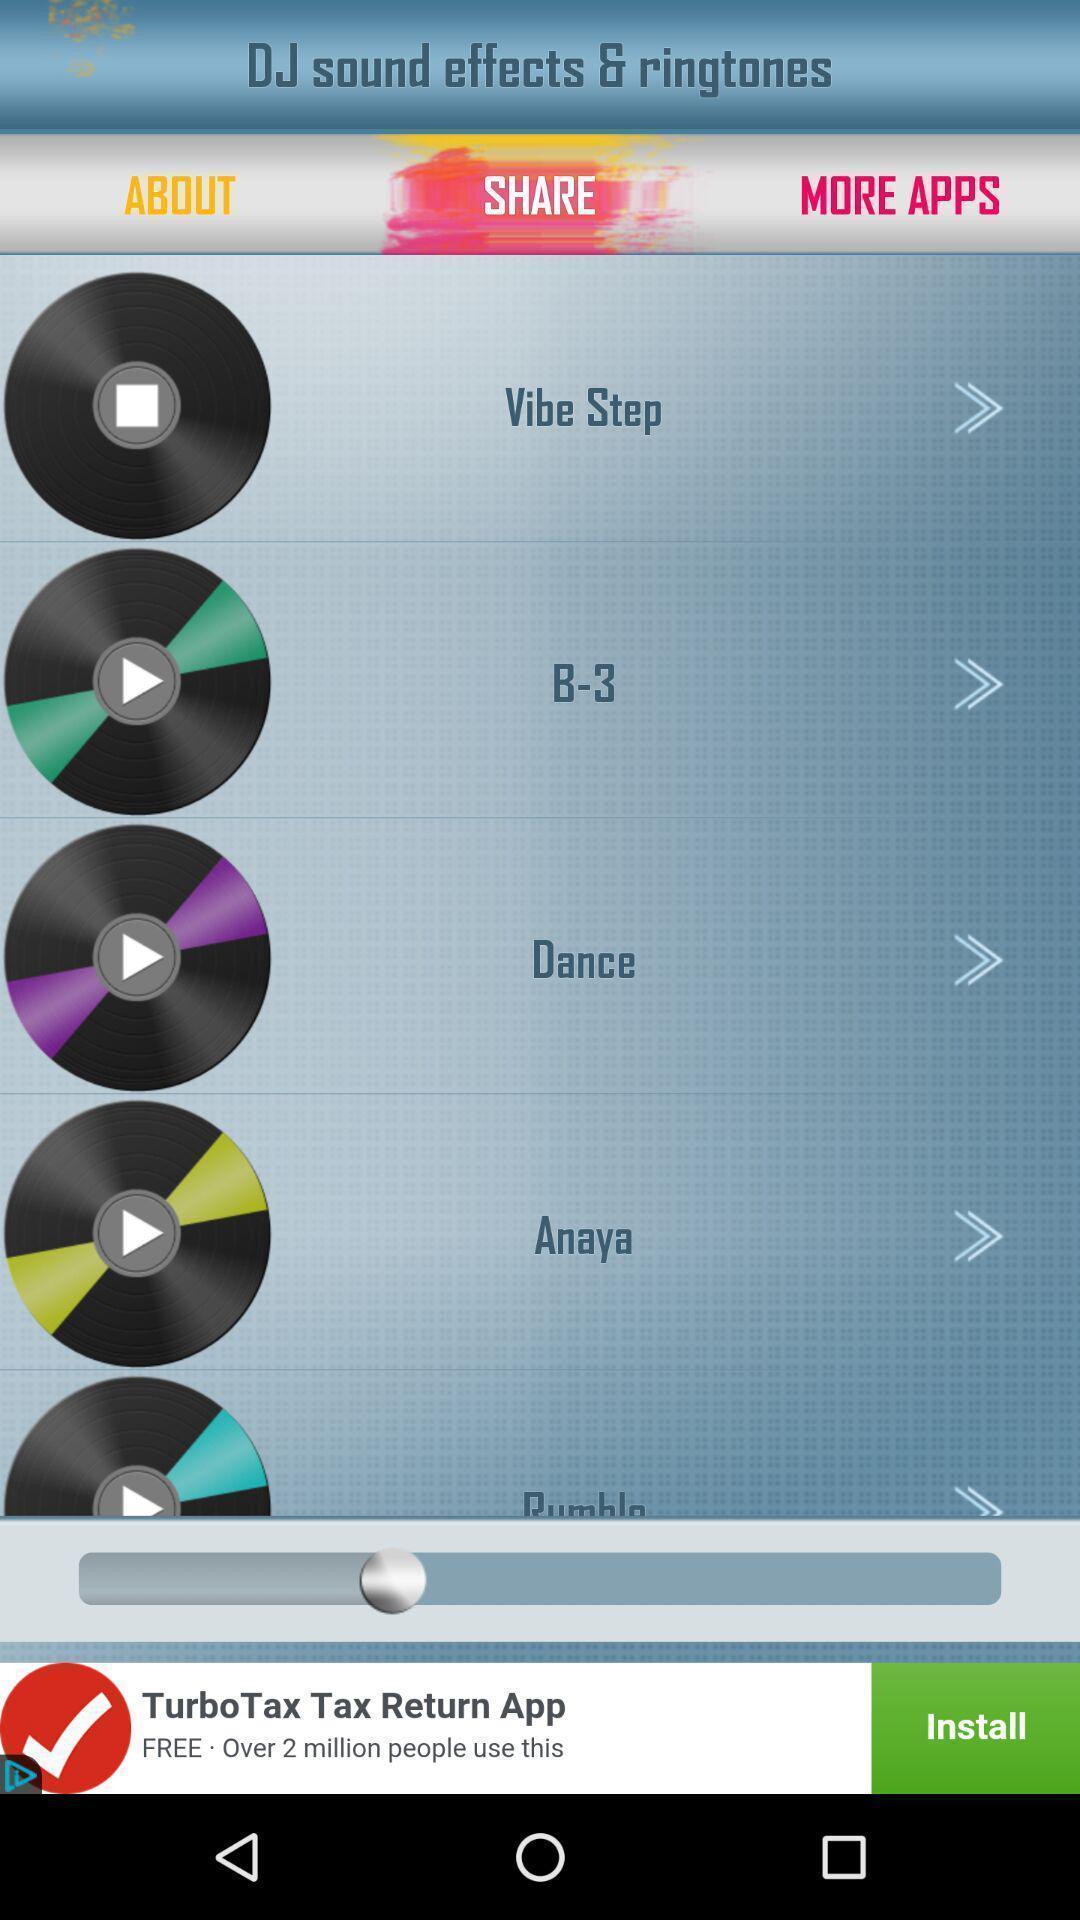Tell me what you see in this picture. Screen displaying options of ringtones and sound effects. 